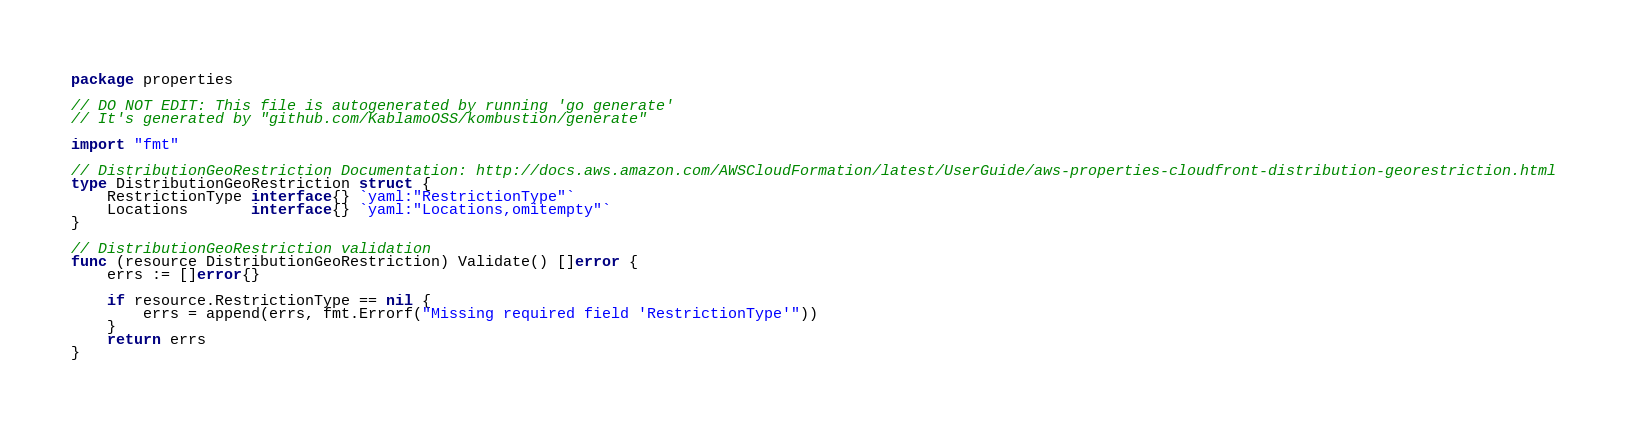<code> <loc_0><loc_0><loc_500><loc_500><_Go_>package properties

// DO NOT EDIT: This file is autogenerated by running 'go generate'
// It's generated by "github.com/KablamoOSS/kombustion/generate"

import "fmt"

// DistributionGeoRestriction Documentation: http://docs.aws.amazon.com/AWSCloudFormation/latest/UserGuide/aws-properties-cloudfront-distribution-georestriction.html
type DistributionGeoRestriction struct {
	RestrictionType interface{} `yaml:"RestrictionType"`
	Locations       interface{} `yaml:"Locations,omitempty"`
}

// DistributionGeoRestriction validation
func (resource DistributionGeoRestriction) Validate() []error {
	errs := []error{}

	if resource.RestrictionType == nil {
		errs = append(errs, fmt.Errorf("Missing required field 'RestrictionType'"))
	}
	return errs
}
</code> 